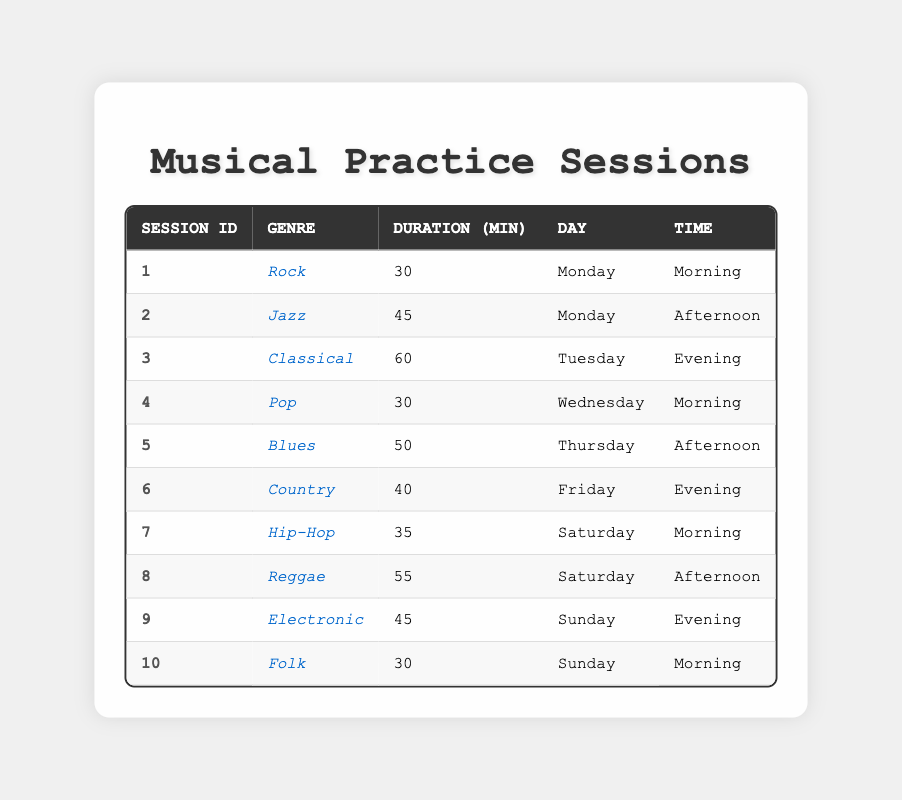What is the longest practice session duration? Looking at the duration column, the longest session is 60 minutes for the genre Classical on Tuesday.
Answer: 60 minutes On which day do I practice Jazz? By checking the table, Jazz is practiced on Monday during the afternoon.
Answer: Monday How many sessions were held in the morning? There are three sessions recorded as held in the morning: Rock on Monday, Pop on Wednesday, and Hip-Hop on Saturday.
Answer: 3 What is the average duration of practice sessions? To find the average, sum all the durations (30 + 45 + 60 + 30 + 50 + 40 + 35 + 55 + 45 + 30 =  420) and divide by the number of sessions (10), which gives an average of 42 minutes.
Answer: 42 minutes Is there a session for the genre Folk on a Saturday? Looking through the table, Folk is practiced on Sunday, not on Saturday. Therefore, the statement is false.
Answer: No Which genre was practiced the most during the sessions? By reviewing the table, every genre appears only once; thus, there is no genre that is repeated. All genres have the same frequency of appearance.
Answer: Each genre is practiced once What is the total practice duration for genres practiced on weekends? The weekend sessions consist of Hip-Hop on Saturday morning (35 minutes), Reggae on Saturday afternoon (55 minutes), Electronic on Sunday evening (45 minutes), and Folk on Sunday morning (30 minutes). The total duration is 35 + 55 + 45 + 30 = 165 minutes.
Answer: 165 minutes What genres have practice sessions longer than 50 minutes? Looking through the table, the genres Classical (60 minutes) and Reggae (55 minutes) have durations exceeding 50 minutes.
Answer: Classical, Reggae 